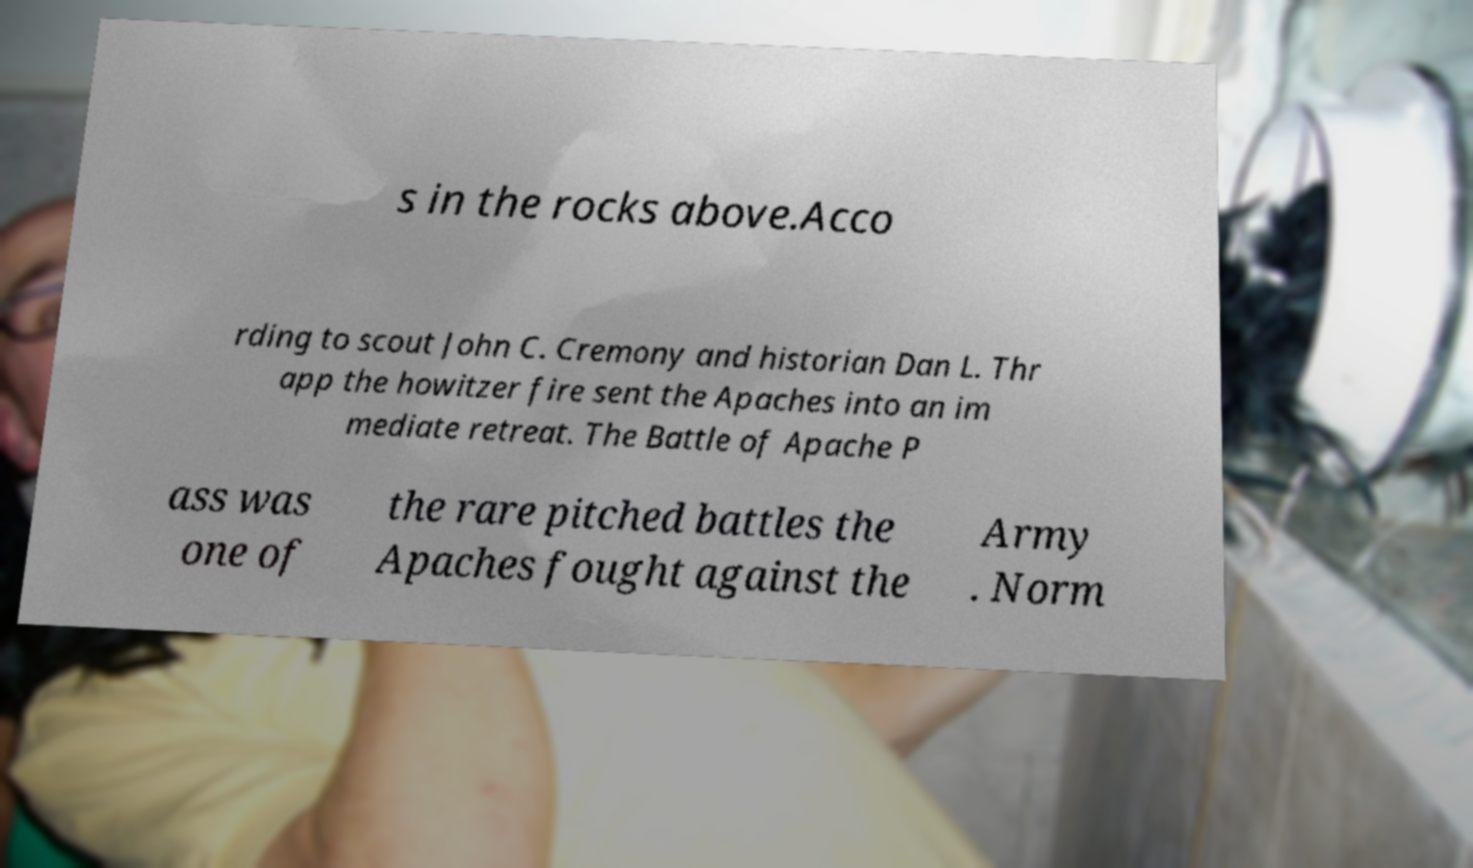I need the written content from this picture converted into text. Can you do that? s in the rocks above.Acco rding to scout John C. Cremony and historian Dan L. Thr app the howitzer fire sent the Apaches into an im mediate retreat. The Battle of Apache P ass was one of the rare pitched battles the Apaches fought against the Army . Norm 